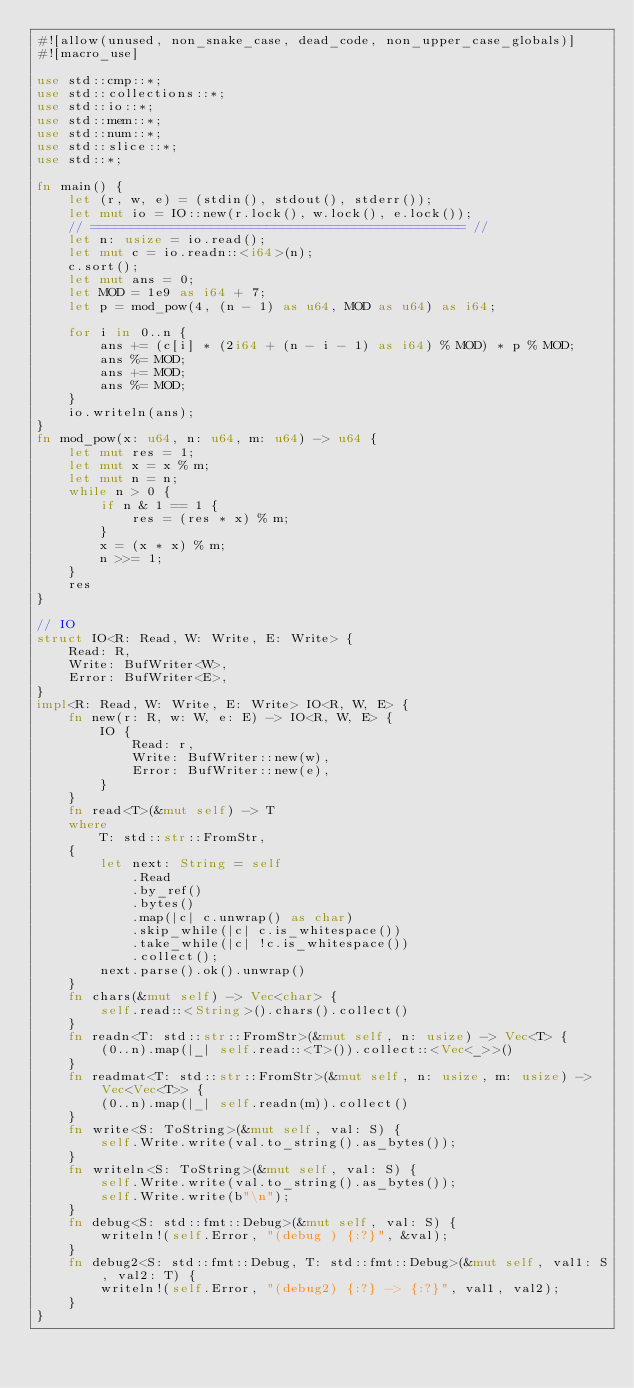<code> <loc_0><loc_0><loc_500><loc_500><_Rust_>#![allow(unused, non_snake_case, dead_code, non_upper_case_globals)]
#![macro_use]

use std::cmp::*;
use std::collections::*;
use std::io::*;
use std::mem::*;
use std::num::*;
use std::slice::*;
use std::*;

fn main() {
    let (r, w, e) = (stdin(), stdout(), stderr());
    let mut io = IO::new(r.lock(), w.lock(), e.lock());
    // =============================================== //
    let n: usize = io.read();
    let mut c = io.readn::<i64>(n);
    c.sort();
    let mut ans = 0;
    let MOD = 1e9 as i64 + 7;
    let p = mod_pow(4, (n - 1) as u64, MOD as u64) as i64;

    for i in 0..n {
        ans += (c[i] * (2i64 + (n - i - 1) as i64) % MOD) * p % MOD;
        ans %= MOD;
        ans += MOD;
        ans %= MOD;
    }
    io.writeln(ans);
}
fn mod_pow(x: u64, n: u64, m: u64) -> u64 {
    let mut res = 1;
    let mut x = x % m;
    let mut n = n;
    while n > 0 {
        if n & 1 == 1 {
            res = (res * x) % m;
        }
        x = (x * x) % m;
        n >>= 1;
    }
    res
}

// IO
struct IO<R: Read, W: Write, E: Write> {
    Read: R,
    Write: BufWriter<W>,
    Error: BufWriter<E>,
}
impl<R: Read, W: Write, E: Write> IO<R, W, E> {
    fn new(r: R, w: W, e: E) -> IO<R, W, E> {
        IO {
            Read: r,
            Write: BufWriter::new(w),
            Error: BufWriter::new(e),
        }
    }
    fn read<T>(&mut self) -> T
    where
        T: std::str::FromStr,
    {
        let next: String = self
            .Read
            .by_ref()
            .bytes()
            .map(|c| c.unwrap() as char)
            .skip_while(|c| c.is_whitespace())
            .take_while(|c| !c.is_whitespace())
            .collect();
        next.parse().ok().unwrap()
    }
    fn chars(&mut self) -> Vec<char> {
        self.read::<String>().chars().collect()
    }
    fn readn<T: std::str::FromStr>(&mut self, n: usize) -> Vec<T> {
        (0..n).map(|_| self.read::<T>()).collect::<Vec<_>>()
    }
    fn readmat<T: std::str::FromStr>(&mut self, n: usize, m: usize) -> Vec<Vec<T>> {
        (0..n).map(|_| self.readn(m)).collect()
    }
    fn write<S: ToString>(&mut self, val: S) {
        self.Write.write(val.to_string().as_bytes());
    }
    fn writeln<S: ToString>(&mut self, val: S) {
        self.Write.write(val.to_string().as_bytes());
        self.Write.write(b"\n");
    }
    fn debug<S: std::fmt::Debug>(&mut self, val: S) {
        writeln!(self.Error, "(debug ) {:?}", &val);
    }
    fn debug2<S: std::fmt::Debug, T: std::fmt::Debug>(&mut self, val1: S, val2: T) {
        writeln!(self.Error, "(debug2) {:?} -> {:?}", val1, val2);
    }
}
</code> 